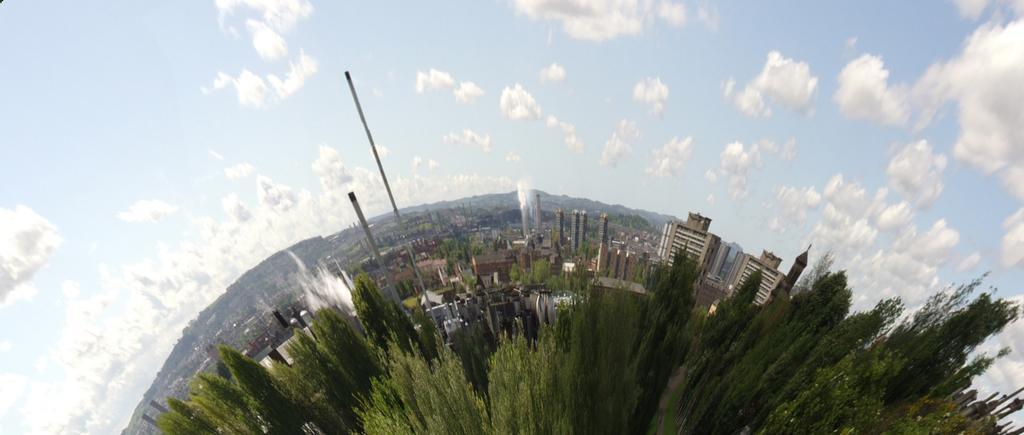In one or two sentences, can you explain what this image depicts? We can see trees, buildings, poles and sky with clouds. 